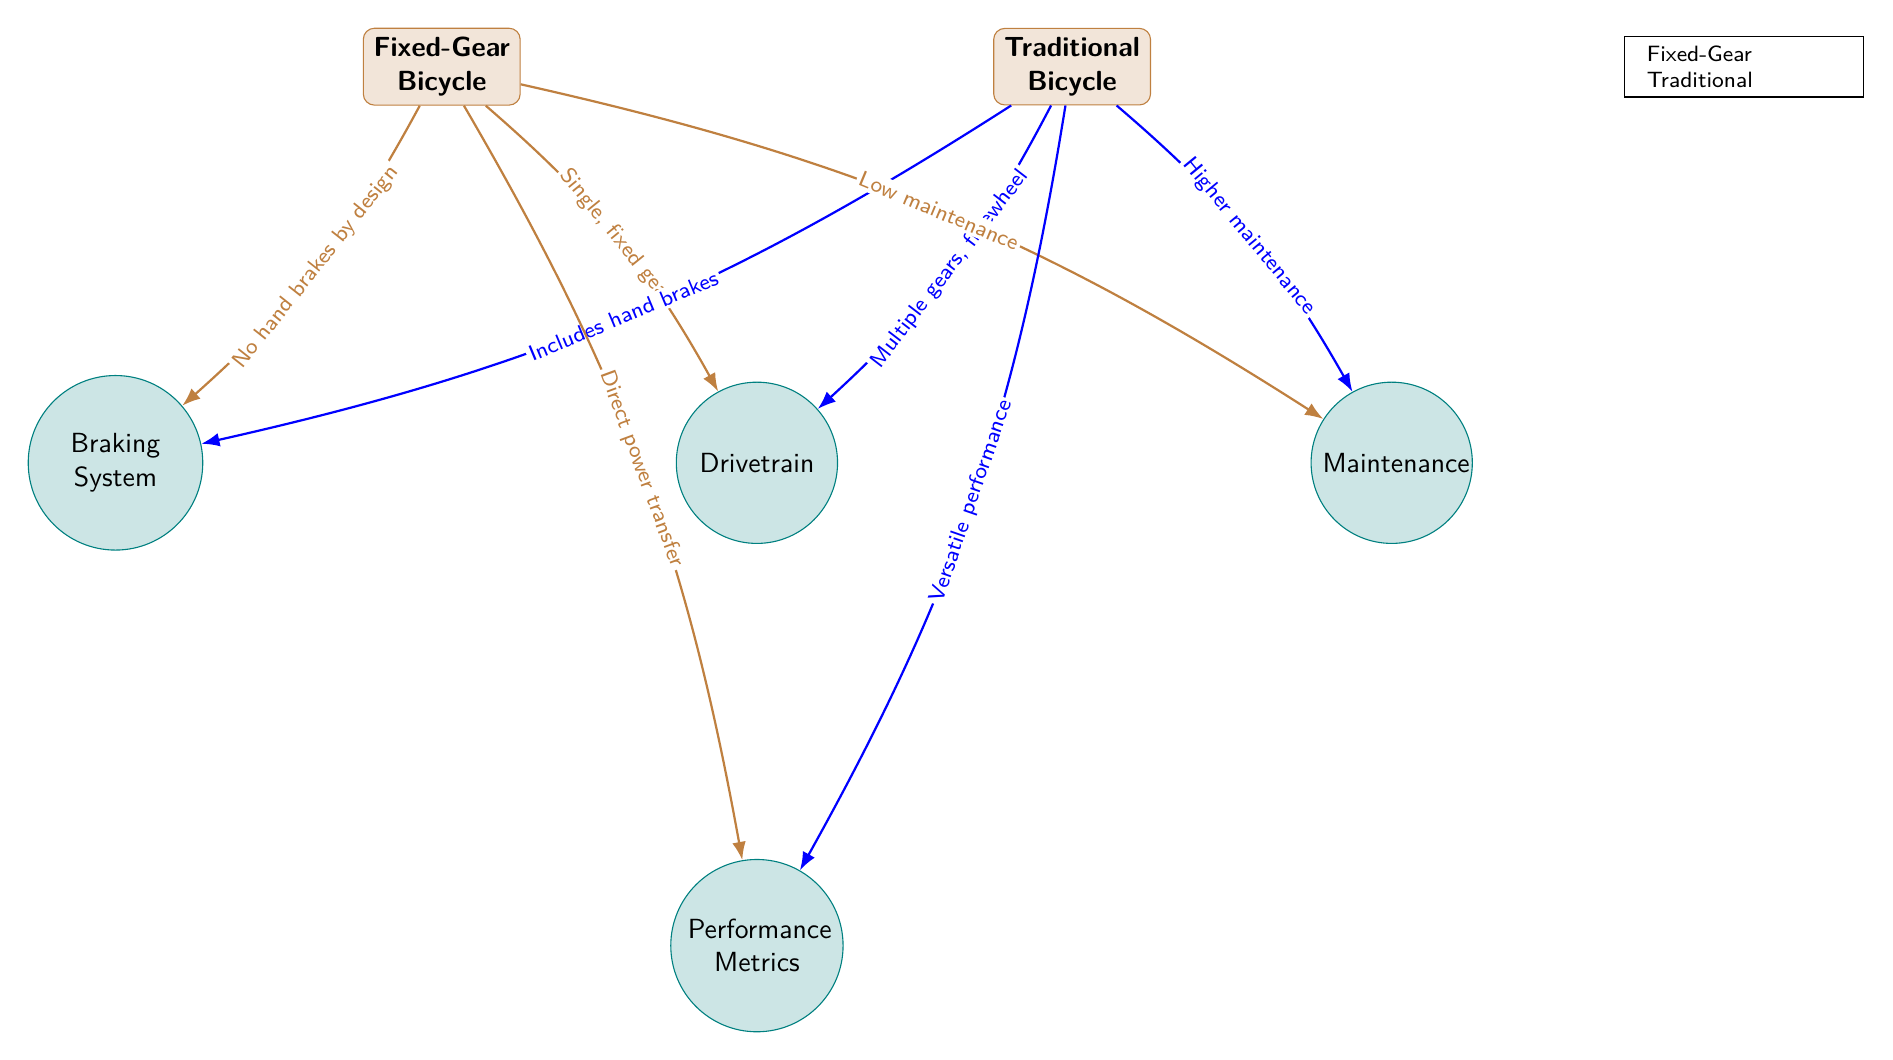What is the primary drivetrain configuration of a Fixed-Gear Bicycle? From the diagram, the Fixed-Gear Bicycle is connected to the drivetrain node with the label "Single, fixed gear." This indicates that the primary configuration for the drivetrain in a fixed-gear bicycle is a single fixed gear.
Answer: Single, fixed gear What braking system feature is unique to the Traditional Bicycle? The edge connecting the Traditional Bicycle to the braking system node reads “Includes hand brakes.” This indicates that traditional bicycles have hand brakes as a characteristic feature that distinguishes them from fixed-gear bicycles.
Answer: Includes hand brakes How many components are listed in the diagram? There are four components in the diagram: Drivetrain, Braking System, Maintenance, and Performance Metrics. Counting these nodes gives a total of four distinct components.
Answer: Four Which bicycle type has lower maintenance according to the diagram? Referring to the maintenance component in the diagram, the edge leading from the Fixed-Gear Bicycle indicates “Low maintenance,” while the Traditional Bicycle shows “Higher maintenance.” This means that the fixed-gear bike requires less maintenance compared to the traditional bicycle.
Answer: Fixed-Gear Bicycle What is the performance metric associated with a Fixed-Gear Bicycle? The Fixed-Gear Bicycle connects to the performance metrics node with the label "Direct power transfer." This indicates that the performance metric specifically associated with a fixed-gear bicycle emphasizes its ability for direct power transfer.
Answer: Direct power transfer Which bicycle type has versatile performance according to the diagram? The edge leading from the Traditional Bicycle to the performance metrics node states "Versatile performance." This indicates that the traditional bicycle is characterized by having versatile performance metrics compared to the fixed gear.
Answer: Traditional Bicycle What type of gear mechanism does the Fixed-Gear Bicycle use? The Fixed-Gear Bicycle is connected to the drivetrain with the description "Single, fixed gear." This specifies the type of gear mechanism it utilizes, which is a single and fixed gear, indicating no ability to change gears.
Answer: Single, fixed gear What can be inferred about the maintenance requirements of a Traditional Bicycle relative to a Fixed-Gear Bicycle? The diagram displays that for the Fixed-Gear Bicycle, maintenance is labeled as "Low maintenance," while for the Traditional Bicycle, it is labeled as "Higher maintenance." Thus, we can infer that a Traditional Bicycle generally necessitates more maintenance compared to a Fixed-Gear Bicycle.
Answer: Higher maintenance 